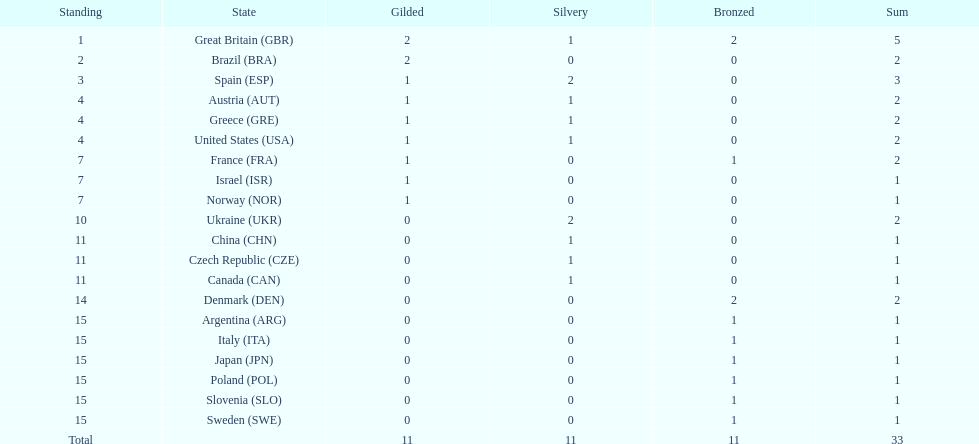Which nation was the only one to receive 3 medals? Spain (ESP). 